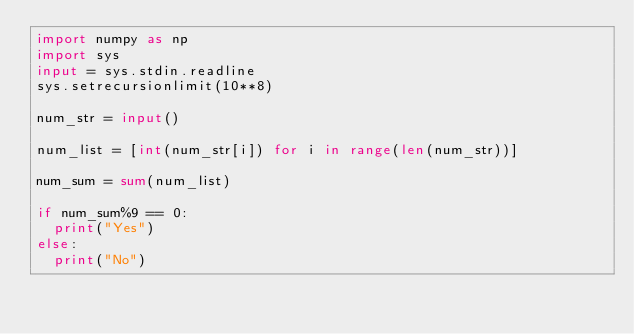<code> <loc_0><loc_0><loc_500><loc_500><_Python_>import numpy as np
import sys
input = sys.stdin.readline
sys.setrecursionlimit(10**8)

num_str = input()

num_list = [int(num_str[i]) for i in range(len(num_str))]

num_sum = sum(num_list)

if num_sum%9 == 0:
  print("Yes")
else:
  print("No")</code> 